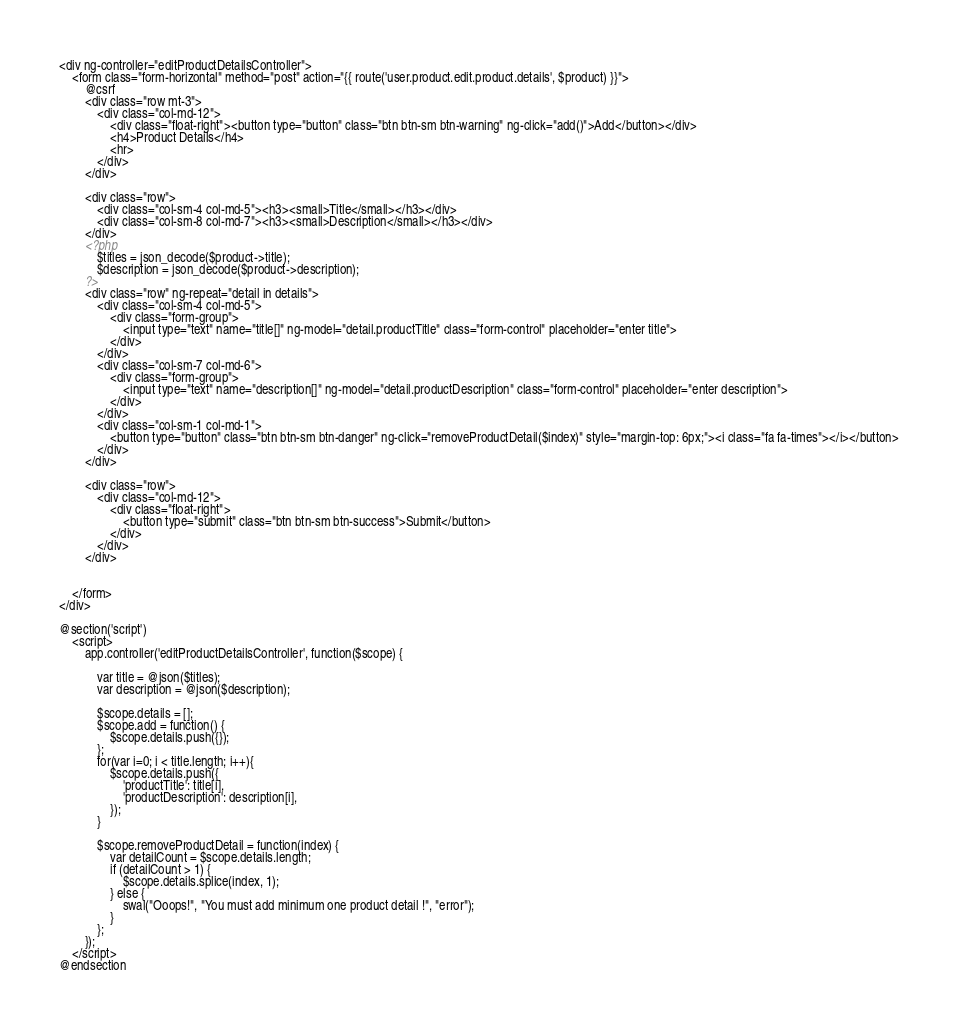Convert code to text. <code><loc_0><loc_0><loc_500><loc_500><_PHP_><div ng-controller="editProductDetailsController">
    <form class="form-horizontal" method="post" action="{{ route('user.product.edit.product.details', $product) }}">
        @csrf
        <div class="row mt-3">
            <div class="col-md-12">
                <div class="float-right"><button type="button" class="btn btn-sm btn-warning" ng-click="add()">Add</button></div>
                <h4>Product Details</h4>
                <hr>
            </div>
        </div>

        <div class="row">
            <div class="col-sm-4 col-md-5"><h3><small>Title</small></h3></div>
            <div class="col-sm-8 col-md-7"><h3><small>Description</small></h3></div>
        </div>
        <?php
            $titles = json_decode($product->title);
            $description = json_decode($product->description);
        ?>
        <div class="row" ng-repeat="detail in details">
            <div class="col-sm-4 col-md-5">
                <div class="form-group">
                    <input type="text" name="title[]" ng-model="detail.productTitle" class="form-control" placeholder="enter title">
                </div>
            </div>
            <div class="col-sm-7 col-md-6">
                <div class="form-group">
                    <input type="text" name="description[]" ng-model="detail.productDescription" class="form-control" placeholder="enter description">
                </div>
            </div>
            <div class="col-sm-1 col-md-1">
                <button type="button" class="btn btn-sm btn-danger" ng-click="removeProductDetail($index)" style="margin-top: 6px;"><i class="fa fa-times"></i></button>
            </div>
        </div>

        <div class="row">
            <div class="col-md-12">
                <div class="float-right">
                    <button type="submit" class="btn btn-sm btn-success">Submit</button>
                </div>
            </div>
        </div>


    </form>
</div>

@section('script')
    <script>
        app.controller('editProductDetailsController', function($scope) {

            var title = @json($titles);
            var description = @json($description);

            $scope.details = [];
            $scope.add = function() {
                $scope.details.push({});
            };
            for(var i=0; i < title.length; i++){
                $scope.details.push({
                    'productTitle': title[i],
                    'productDescription': description[i],
                });
            }

            $scope.removeProductDetail = function(index) {
                var detailCount = $scope.details.length;
                if (detailCount > 1) {
                    $scope.details.splice(index, 1);
                } else {
                    swal("Ooops!", "You must add minimum one product detail !", "error");
                }
            };
        });
    </script>
@endsection</code> 